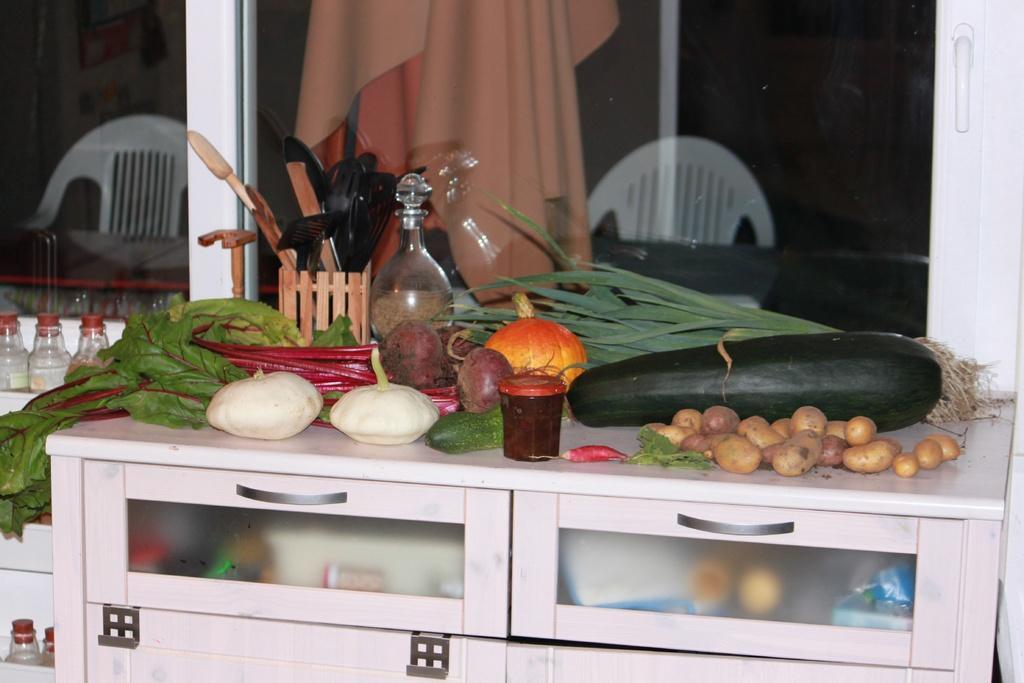How would you summarize this image in a sentence or two? In the picture I can see few vegetables which are placed on the table and there are few other objects behind it and there is a glass window which has two chairs and some other objects in the background. 